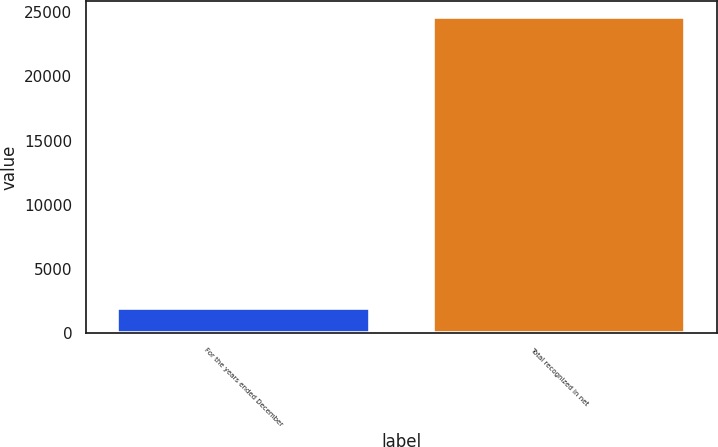Convert chart. <chart><loc_0><loc_0><loc_500><loc_500><bar_chart><fcel>For the years ended December<fcel>Total recognized in net<nl><fcel>2005<fcel>24624<nl></chart> 